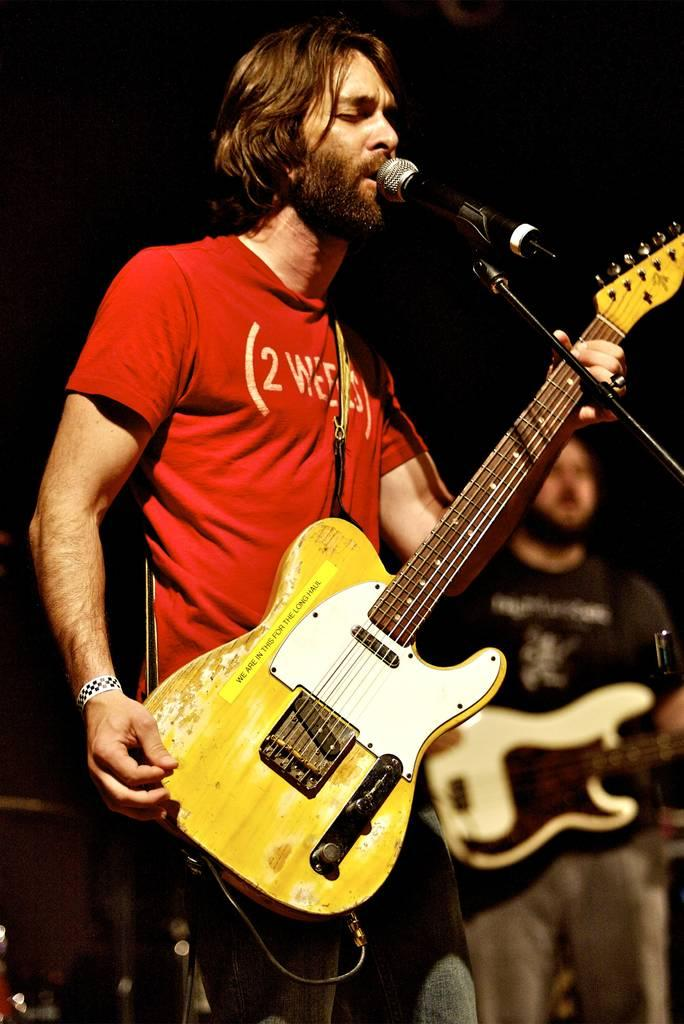What is the person in the red T-shirt doing in the image? The person in the red T-shirt is standing in front of a mic and holding a guitar. Can you describe the second person in the image? The second person is also standing and holding a guitar. What color is the T-shirt of the person in the image? The person in the red T-shirt is wearing a red T-shirt. How many sheep are visible in the image? There are no sheep present in the image. What page of the book is the person reading in the image? There is no book or reading activity depicted in the image. 